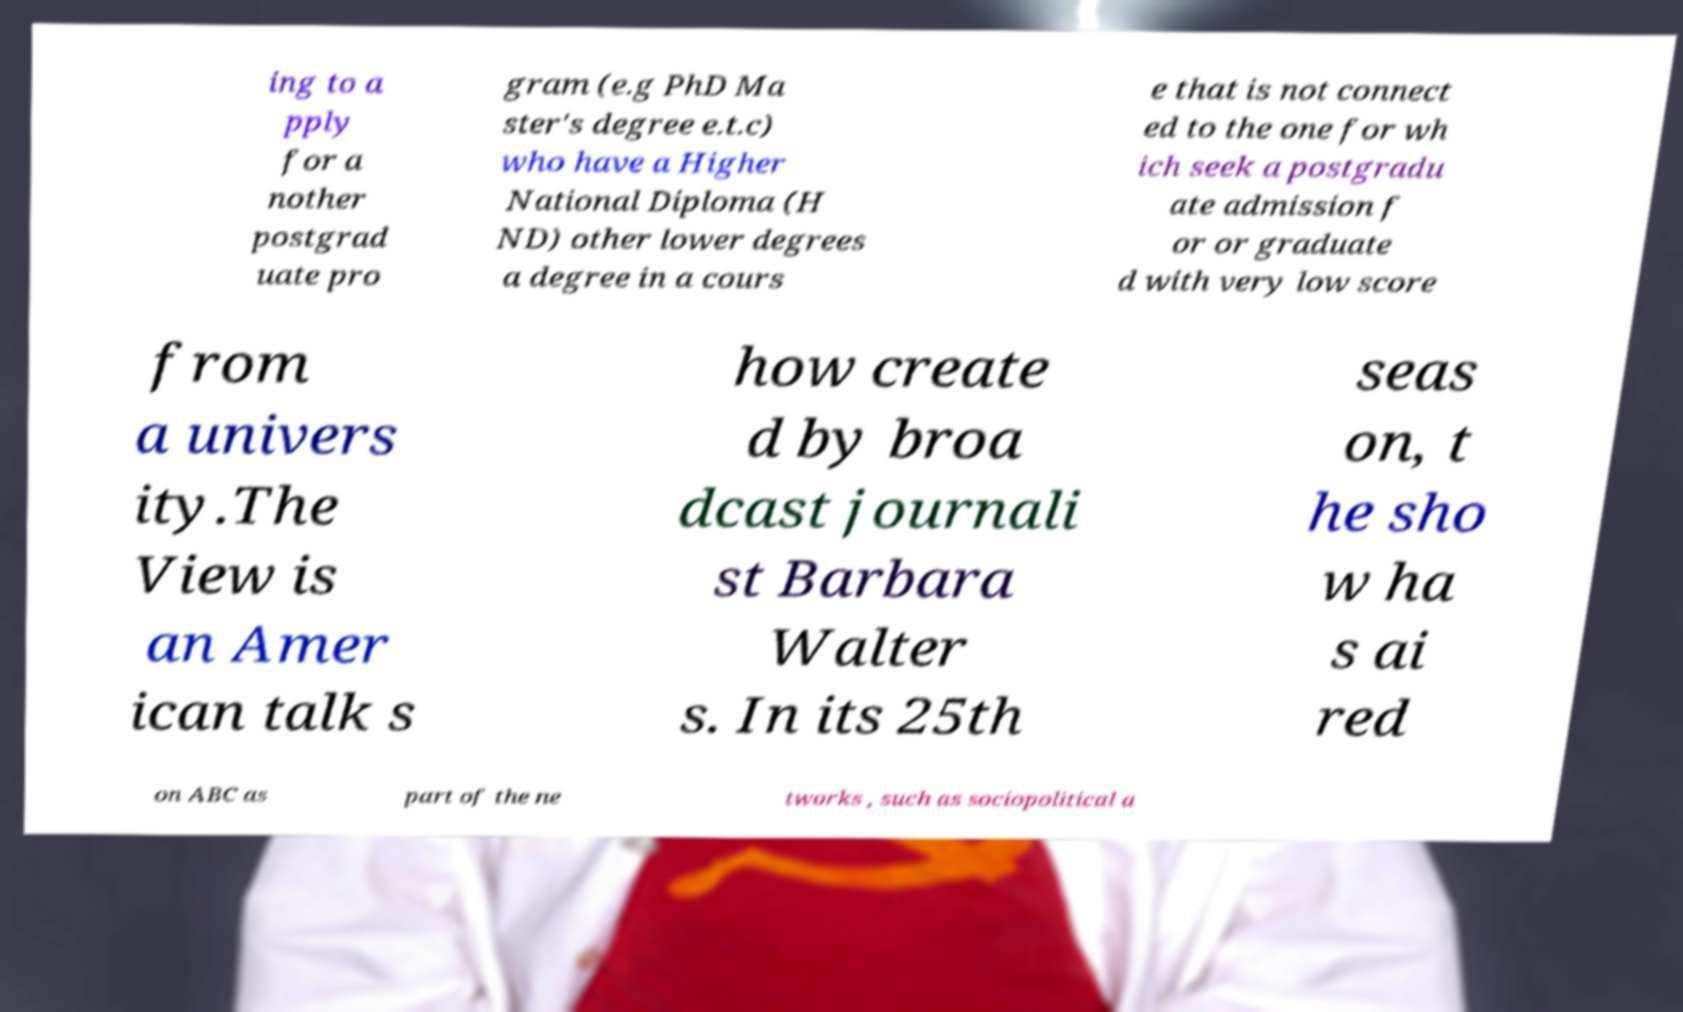I need the written content from this picture converted into text. Can you do that? ing to a pply for a nother postgrad uate pro gram (e.g PhD Ma ster's degree e.t.c) who have a Higher National Diploma (H ND) other lower degrees a degree in a cours e that is not connect ed to the one for wh ich seek a postgradu ate admission f or or graduate d with very low score from a univers ity.The View is an Amer ican talk s how create d by broa dcast journali st Barbara Walter s. In its 25th seas on, t he sho w ha s ai red on ABC as part of the ne tworks , such as sociopolitical a 